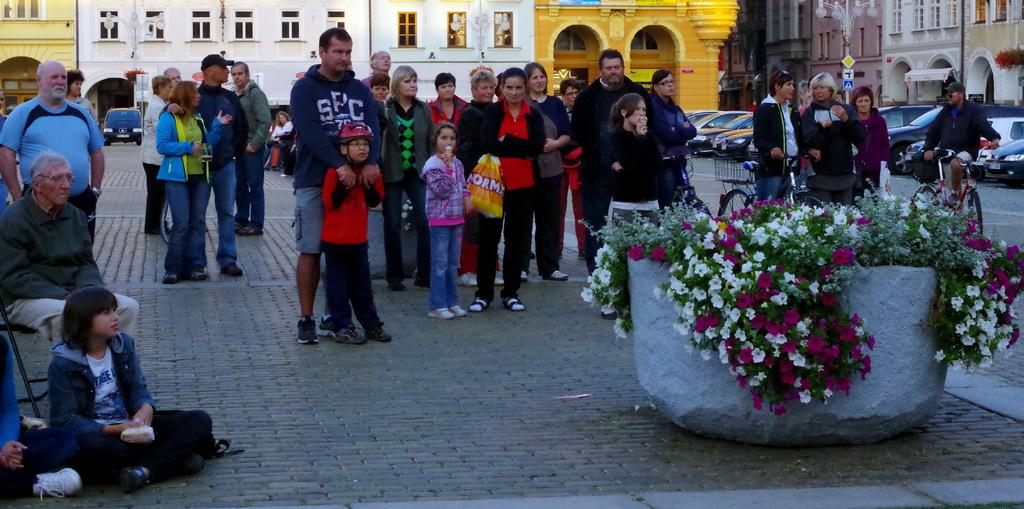Who or what can be seen in the image? There are people in the image. What type of structures are visible in the image? There are buildings in the image. What else can be seen moving in the image? There are vehicles in the image. What are the vertical structures in the image used for? There are poles in the image, which may be used for various purposes such as lighting or signage. What are the flat, rectangular objects in the image? There are boards in the image, which could be signs or advertisements. What is the surface that the people, buildings, vehicles, poles, and boards are situated on? There is ground visible in the image. What type of object in the image contains plants and flowers? There is an object with plants and flowers in the image. What type of drink is being consumed by the team in the image? There is no team or drink present in the image. What part of the human body is visible in the image? There are no human body parts visible in the image. 